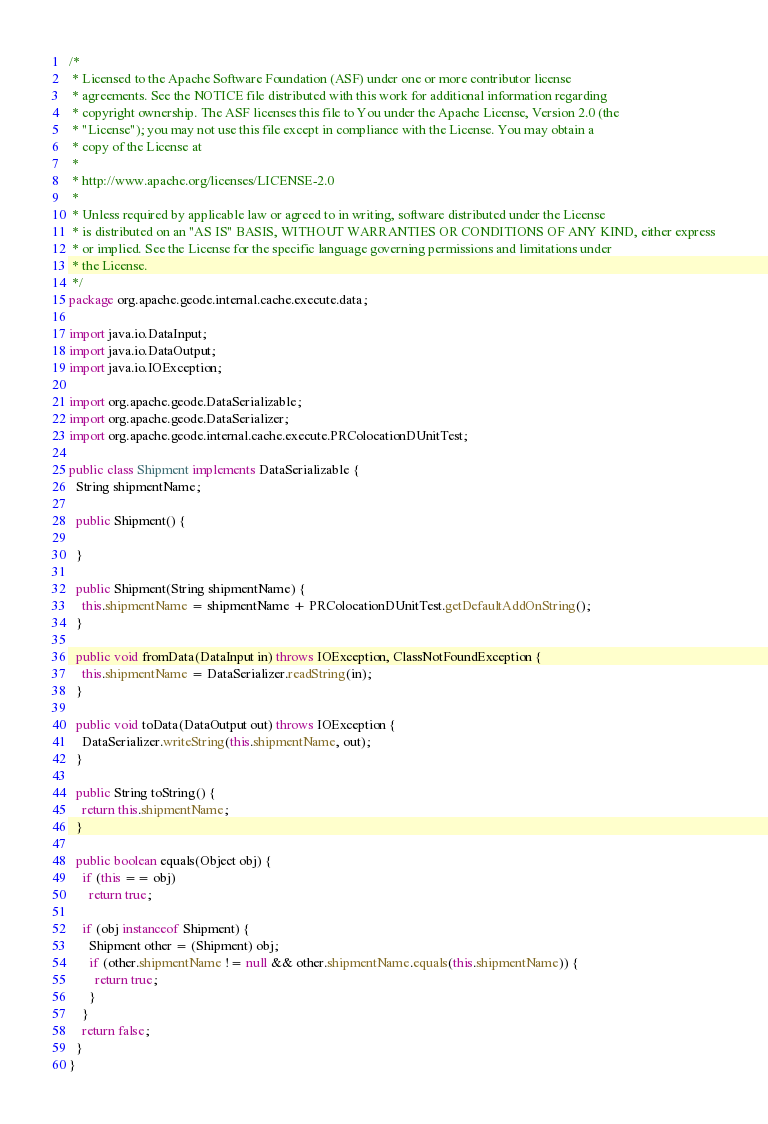Convert code to text. <code><loc_0><loc_0><loc_500><loc_500><_Java_>/*
 * Licensed to the Apache Software Foundation (ASF) under one or more contributor license
 * agreements. See the NOTICE file distributed with this work for additional information regarding
 * copyright ownership. The ASF licenses this file to You under the Apache License, Version 2.0 (the
 * "License"); you may not use this file except in compliance with the License. You may obtain a
 * copy of the License at
 *
 * http://www.apache.org/licenses/LICENSE-2.0
 *
 * Unless required by applicable law or agreed to in writing, software distributed under the License
 * is distributed on an "AS IS" BASIS, WITHOUT WARRANTIES OR CONDITIONS OF ANY KIND, either express
 * or implied. See the License for the specific language governing permissions and limitations under
 * the License.
 */
package org.apache.geode.internal.cache.execute.data;

import java.io.DataInput;
import java.io.DataOutput;
import java.io.IOException;

import org.apache.geode.DataSerializable;
import org.apache.geode.DataSerializer;
import org.apache.geode.internal.cache.execute.PRColocationDUnitTest;

public class Shipment implements DataSerializable {
  String shipmentName;

  public Shipment() {

  }

  public Shipment(String shipmentName) {
    this.shipmentName = shipmentName + PRColocationDUnitTest.getDefaultAddOnString();
  }

  public void fromData(DataInput in) throws IOException, ClassNotFoundException {
    this.shipmentName = DataSerializer.readString(in);
  }

  public void toData(DataOutput out) throws IOException {
    DataSerializer.writeString(this.shipmentName, out);
  }

  public String toString() {
    return this.shipmentName;
  }

  public boolean equals(Object obj) {
    if (this == obj)
      return true;

    if (obj instanceof Shipment) {
      Shipment other = (Shipment) obj;
      if (other.shipmentName != null && other.shipmentName.equals(this.shipmentName)) {
        return true;
      }
    }
    return false;
  }
}
</code> 